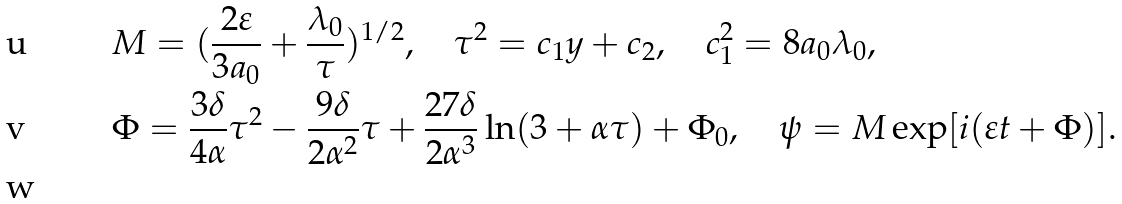<formula> <loc_0><loc_0><loc_500><loc_500>& M = ( \frac { 2 \varepsilon } { 3 a _ { 0 } } + \frac { \lambda _ { 0 } } { \tau } ) ^ { 1 / 2 } , \quad \tau ^ { 2 } = c _ { 1 } y + c _ { 2 } , \quad c _ { 1 } ^ { 2 } = 8 a _ { 0 } \lambda _ { 0 } , \\ & \Phi = \frac { 3 \delta } { 4 \alpha } \tau ^ { 2 } - \frac { 9 \delta } { 2 \alpha ^ { 2 } } \tau + \frac { 2 7 \delta } { 2 \alpha ^ { 3 } } \ln ( 3 + \alpha \tau ) + \Phi _ { 0 } , \quad \psi = M \exp [ i ( \varepsilon t + \Phi ) ] . \\</formula> 